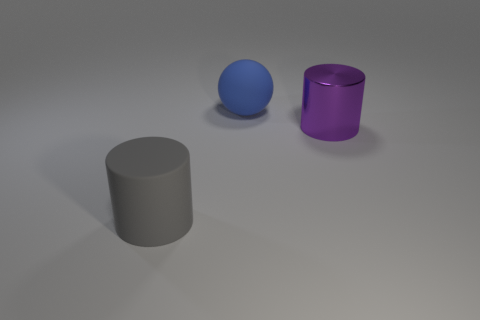How big is the thing that is to the right of the rubber cylinder and to the left of the big purple thing?
Keep it short and to the point. Large. Is the number of small brown shiny blocks greater than the number of big balls?
Your response must be concise. No. Is the number of small blue metal objects less than the number of big things?
Ensure brevity in your answer.  Yes. Are there any gray cylinders that have the same material as the purple thing?
Your answer should be very brief. No. There is a rubber object in front of the large purple cylinder; what shape is it?
Make the answer very short. Cylinder. Is the number of purple cylinders in front of the big purple thing less than the number of blue balls?
Your answer should be compact. Yes. There is a large ball that is the same material as the large gray thing; what color is it?
Offer a very short reply. Blue. Are the large blue object and the purple thing made of the same material?
Offer a terse response. No. Are there any large gray rubber things that are right of the matte thing left of the large matte thing that is behind the large gray cylinder?
Keep it short and to the point. No. What is the color of the large shiny thing?
Give a very brief answer. Purple. 